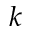Convert formula to latex. <formula><loc_0><loc_0><loc_500><loc_500>k</formula> 